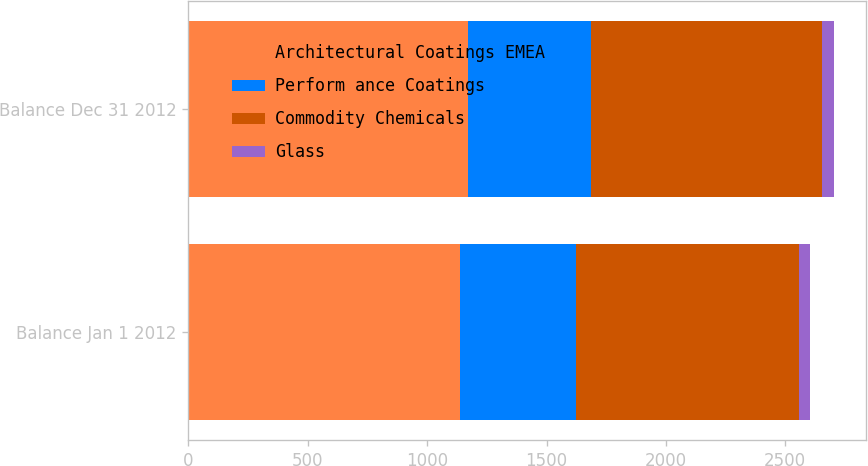<chart> <loc_0><loc_0><loc_500><loc_500><stacked_bar_chart><ecel><fcel>Balance Jan 1 2012<fcel>Balance Dec 31 2012<nl><fcel>Architectural Coatings EMEA<fcel>1139<fcel>1173<nl><fcel>Perform ance Coatings<fcel>484<fcel>512<nl><fcel>Commodity Chemicals<fcel>933<fcel>970<nl><fcel>Glass<fcel>48<fcel>48<nl></chart> 